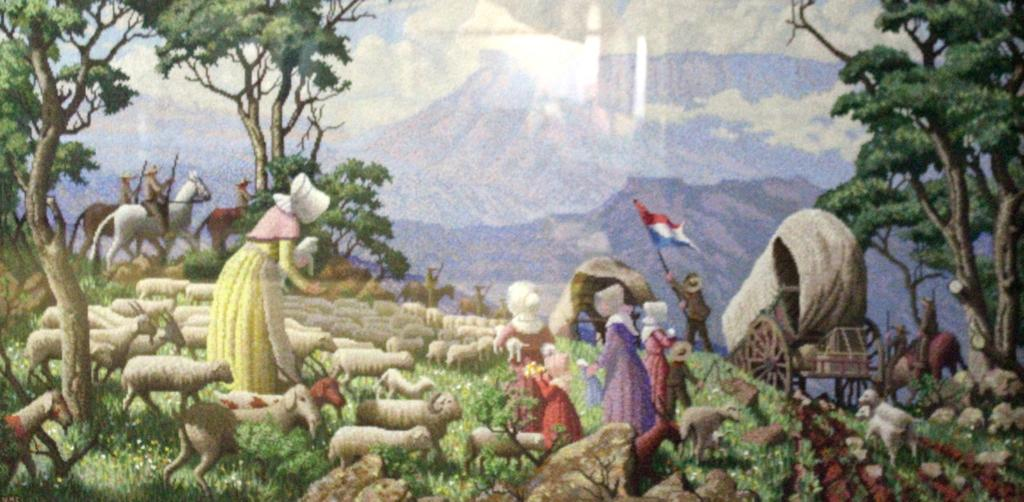What animals are depicted in the painting? The painting contains sheeps. What other subjects are present in the painting? The painting contains people, a cart, and horses. What are some people doing in the painting? Some people are riding horses in the painting. What type of vegetation is present in the painting? There are trees in the painting. What is the chance of winning a lottery in the painting? There is no mention of a lottery or any gambling activity in the painting, so it is not possible to determine the chance of winning a lottery. 